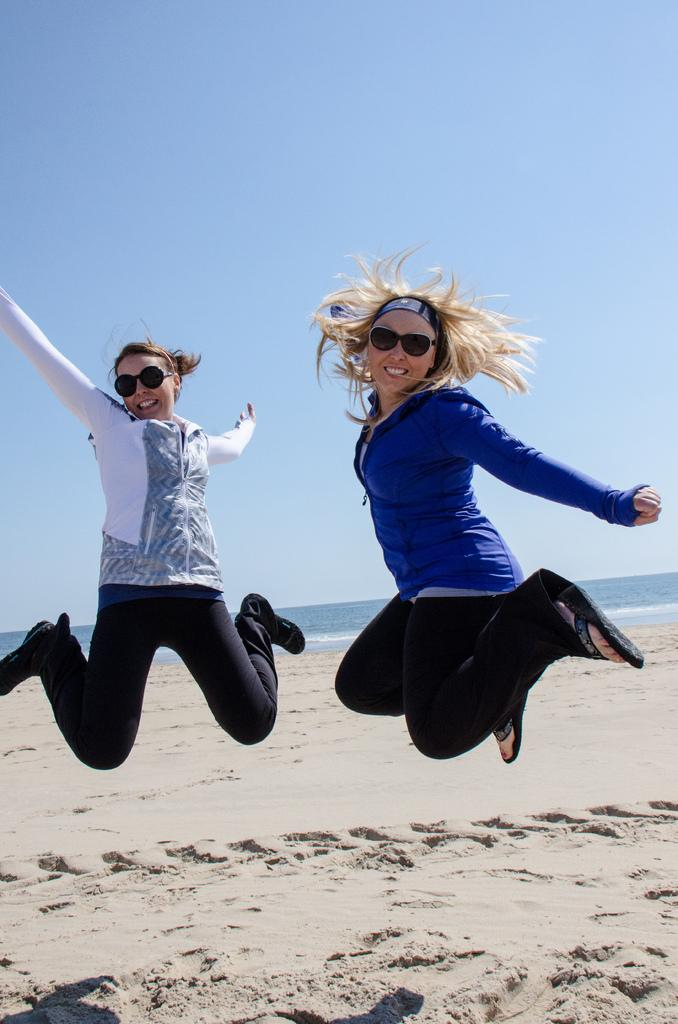How many people are in the image? There are persons in the image. What are the persons doing in the image? The persons are jumping and smiling. What type of surface is under their feet? There is sand on the ground. What can be seen in the background of the image? There is an ocean in the background of the image. How quiet are the jumping persons in the image? The provided facts do not mention the volume or noise level of the persons in the image, so it cannot be determined from the image. 